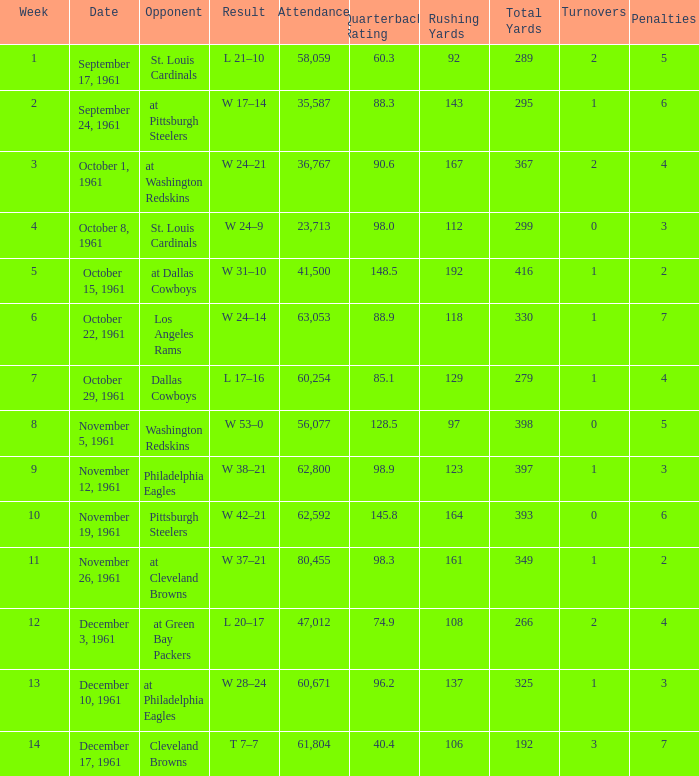Which Week has an Opponent of washington redskins, and an Attendance larger than 56,077? 0.0. 